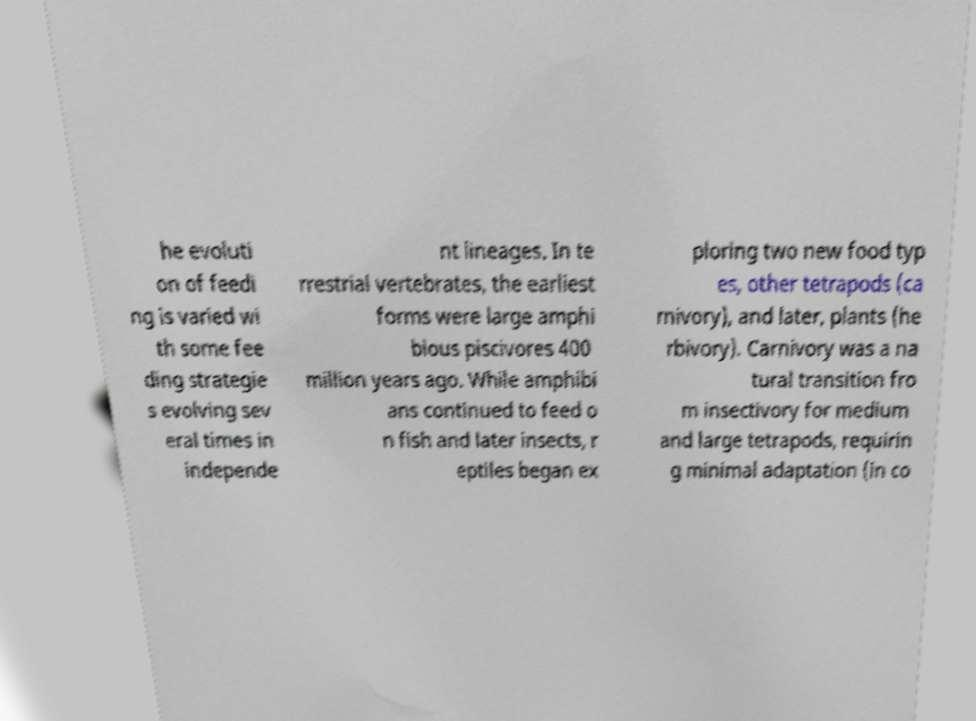What messages or text are displayed in this image? I need them in a readable, typed format. he evoluti on of feedi ng is varied wi th some fee ding strategie s evolving sev eral times in independe nt lineages. In te rrestrial vertebrates, the earliest forms were large amphi bious piscivores 400 million years ago. While amphibi ans continued to feed o n fish and later insects, r eptiles began ex ploring two new food typ es, other tetrapods (ca rnivory), and later, plants (he rbivory). Carnivory was a na tural transition fro m insectivory for medium and large tetrapods, requirin g minimal adaptation (in co 